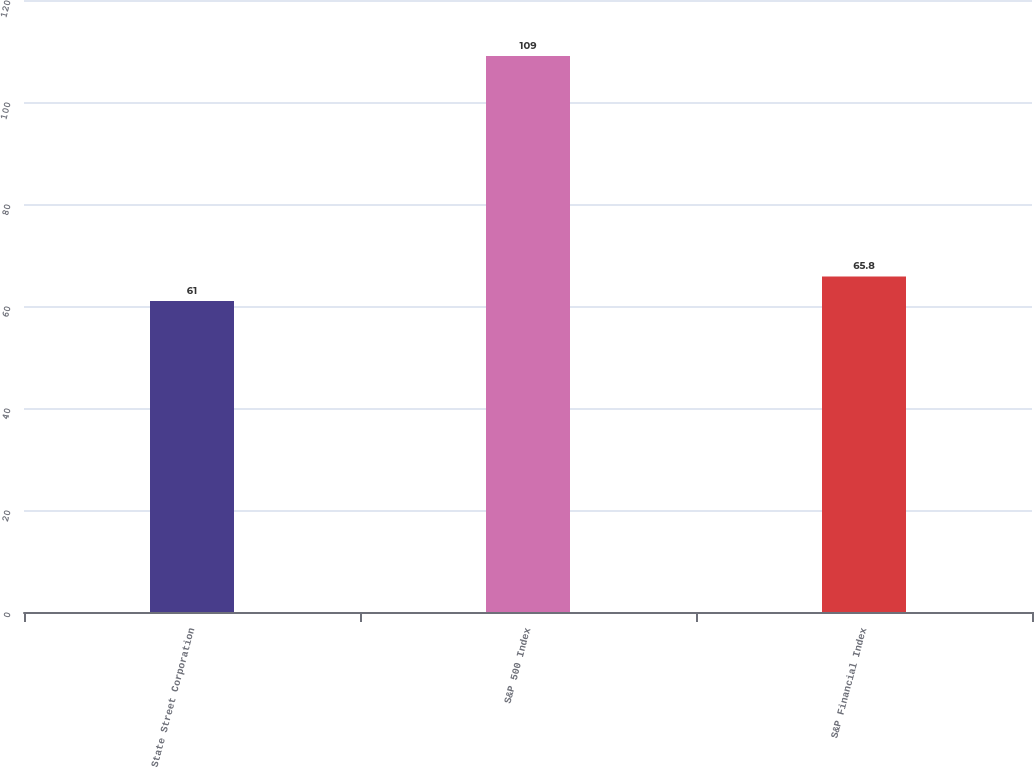Convert chart. <chart><loc_0><loc_0><loc_500><loc_500><bar_chart><fcel>State Street Corporation<fcel>S&P 500 Index<fcel>S&P Financial Index<nl><fcel>61<fcel>109<fcel>65.8<nl></chart> 